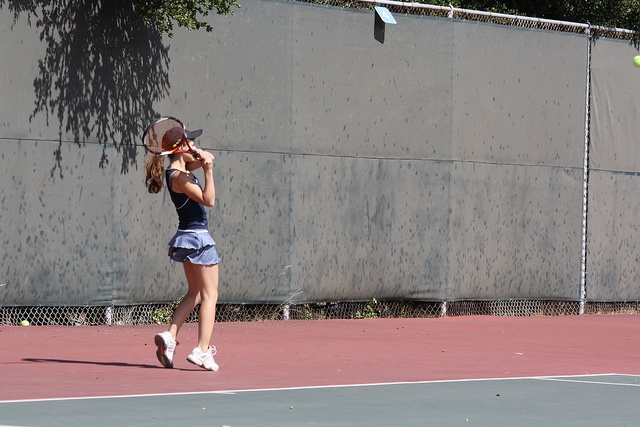Describe the objects in this image and their specific colors. I can see people in gray, maroon, black, lightgray, and lightpink tones, tennis racket in gray, maroon, and black tones, and sports ball in gray, khaki, olive, and darkgray tones in this image. 